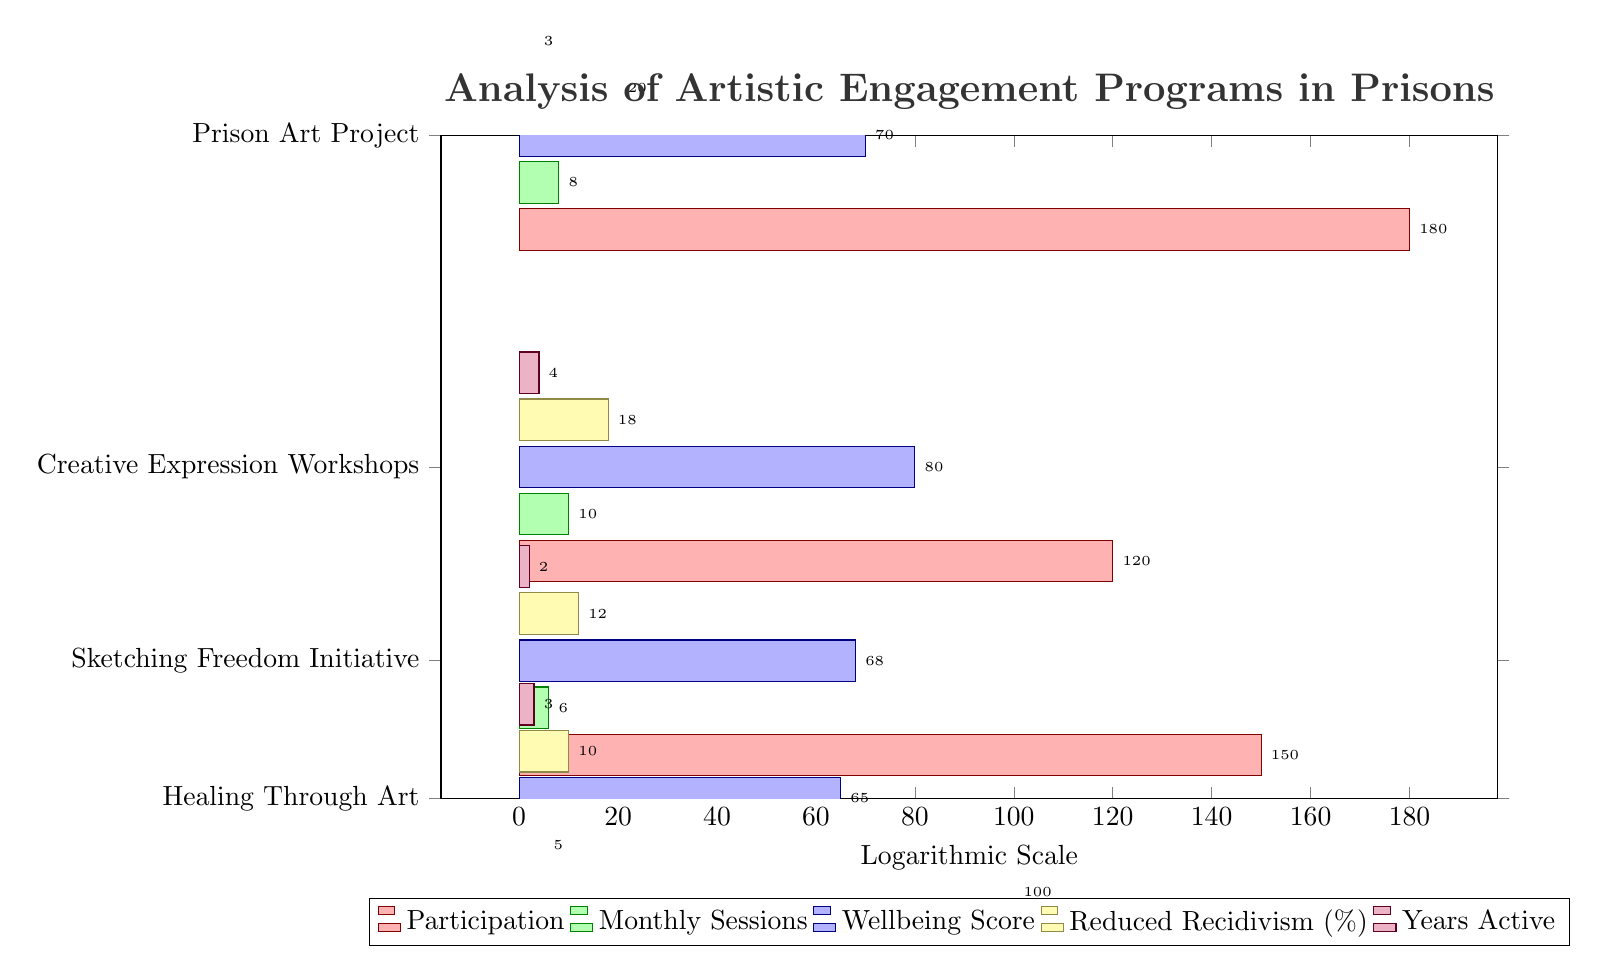What is the inmate participation in the "Prison Art Project"? The table lists the "Prison Art Project" under the program name, and the corresponding inmate participation value is 250.
Answer: 250 Which program has the highest inmate wellbeing score? Looking at the wellbeing scores for each program, "Sketching Freedom Initiative" has the highest score of 80 compared to others like 75 for "Prison Art Project" and 70 for "Creative Expression Workshops".
Answer: Sketching Freedom Initiative What is the total number of monthly sessions across all programs? Summing the monthly sessions: 12 + 8 + 10 + 6 + 5 equals 41.
Answer: 41 Is the recidivism reduction rate higher for the “Creative Expression Workshops” than for “Healing Through Art”? The table indicates that the recidivism rate for "Creative Expression Workshops" is 20%, while "Healing Through Art" has a lower rate of 12%. Thus, it is true that "Creative Expression Workshops" has a higher rate.
Answer: Yes What is the average inmate participation for the programs active for more than 3 years? The programs active for more than 3 years are "Prison Art Project" (5 years) and "Sketching Freedom Initiative" (4 years). Summing their participation gives 250 + 120 = 370. There are 2 programs, so the average is 370 divided by 2, which is 185.
Answer: 185 Which program had fewer than 10 monthly sessions and also the lowest wellbeing score? From the table, "Prison Poetry Initiative" has 5 monthly sessions and a wellbeing score of 65, which is the lowest in both categories compared to others.
Answer: Prison Poetry Initiative How many years has the “Healing Through Art” program been active? The table directly shows that the “Healing Through Art” program has been active for 2 years.
Answer: 2 What is the total reduced recidivism rate for all programs? The recidivism rates for each program are 15% + 20% + 18% + 12% + 10%, which totals to 85%.
Answer: 85% 